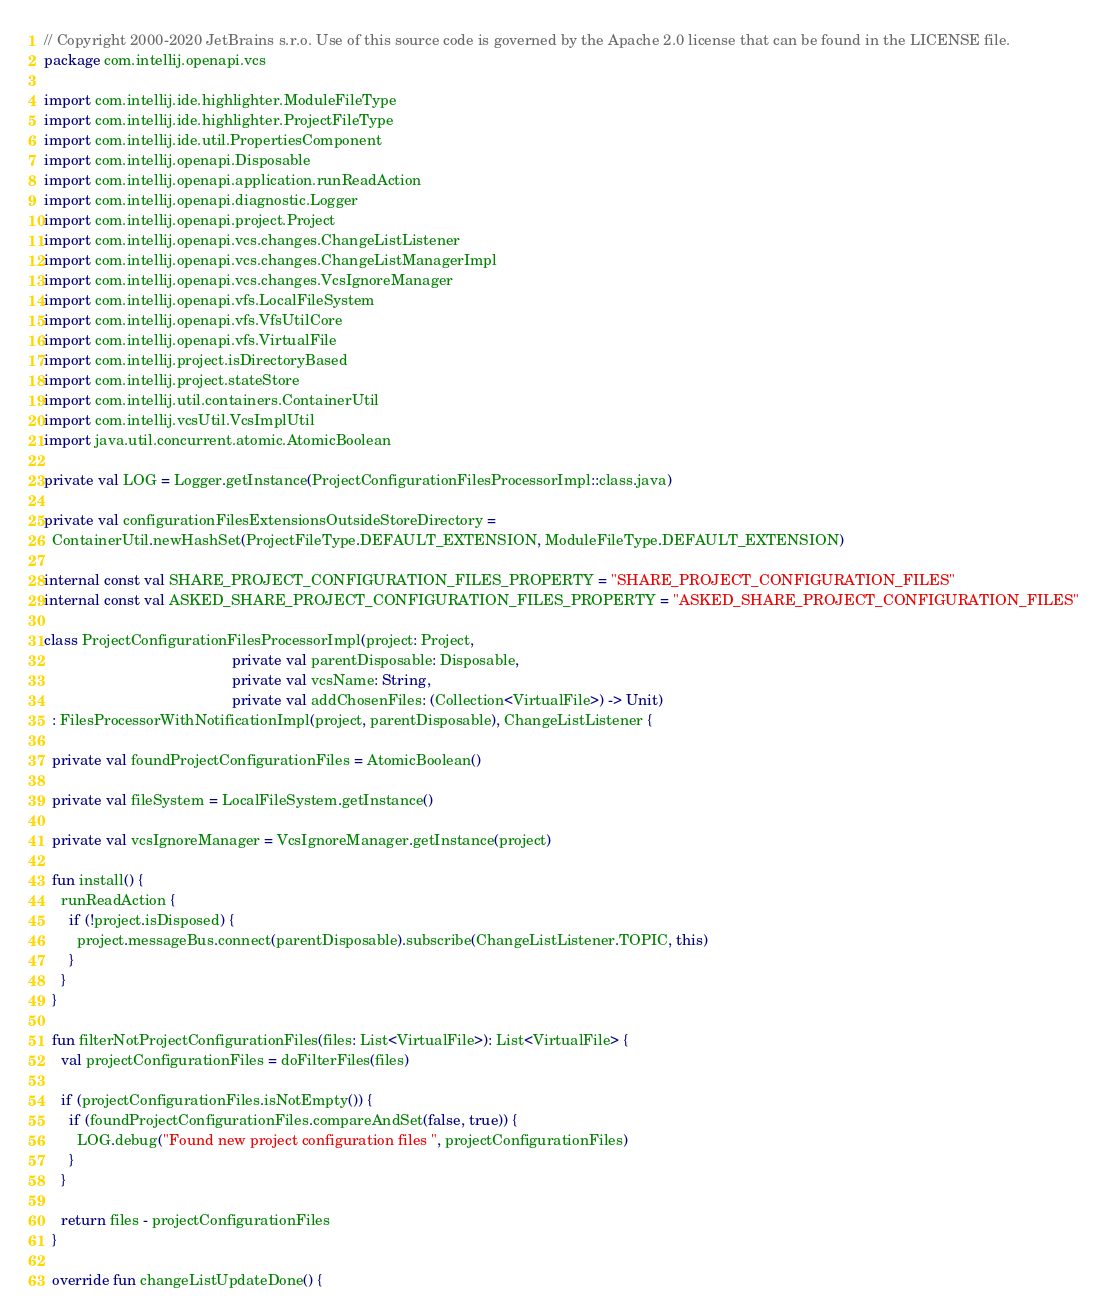Convert code to text. <code><loc_0><loc_0><loc_500><loc_500><_Kotlin_>// Copyright 2000-2020 JetBrains s.r.o. Use of this source code is governed by the Apache 2.0 license that can be found in the LICENSE file.
package com.intellij.openapi.vcs

import com.intellij.ide.highlighter.ModuleFileType
import com.intellij.ide.highlighter.ProjectFileType
import com.intellij.ide.util.PropertiesComponent
import com.intellij.openapi.Disposable
import com.intellij.openapi.application.runReadAction
import com.intellij.openapi.diagnostic.Logger
import com.intellij.openapi.project.Project
import com.intellij.openapi.vcs.changes.ChangeListListener
import com.intellij.openapi.vcs.changes.ChangeListManagerImpl
import com.intellij.openapi.vcs.changes.VcsIgnoreManager
import com.intellij.openapi.vfs.LocalFileSystem
import com.intellij.openapi.vfs.VfsUtilCore
import com.intellij.openapi.vfs.VirtualFile
import com.intellij.project.isDirectoryBased
import com.intellij.project.stateStore
import com.intellij.util.containers.ContainerUtil
import com.intellij.vcsUtil.VcsImplUtil
import java.util.concurrent.atomic.AtomicBoolean

private val LOG = Logger.getInstance(ProjectConfigurationFilesProcessorImpl::class.java)

private val configurationFilesExtensionsOutsideStoreDirectory =
  ContainerUtil.newHashSet(ProjectFileType.DEFAULT_EXTENSION, ModuleFileType.DEFAULT_EXTENSION)

internal const val SHARE_PROJECT_CONFIGURATION_FILES_PROPERTY = "SHARE_PROJECT_CONFIGURATION_FILES"
internal const val ASKED_SHARE_PROJECT_CONFIGURATION_FILES_PROPERTY = "ASKED_SHARE_PROJECT_CONFIGURATION_FILES"

class ProjectConfigurationFilesProcessorImpl(project: Project,
                                             private val parentDisposable: Disposable,
                                             private val vcsName: String,
                                             private val addChosenFiles: (Collection<VirtualFile>) -> Unit)
  : FilesProcessorWithNotificationImpl(project, parentDisposable), ChangeListListener {

  private val foundProjectConfigurationFiles = AtomicBoolean()

  private val fileSystem = LocalFileSystem.getInstance()

  private val vcsIgnoreManager = VcsIgnoreManager.getInstance(project)

  fun install() {
    runReadAction {
      if (!project.isDisposed) {
        project.messageBus.connect(parentDisposable).subscribe(ChangeListListener.TOPIC, this)
      }
    }
  }

  fun filterNotProjectConfigurationFiles(files: List<VirtualFile>): List<VirtualFile> {
    val projectConfigurationFiles = doFilterFiles(files)

    if (projectConfigurationFiles.isNotEmpty()) {
      if (foundProjectConfigurationFiles.compareAndSet(false, true)) {
        LOG.debug("Found new project configuration files ", projectConfigurationFiles)
      }
    }

    return files - projectConfigurationFiles
  }

  override fun changeListUpdateDone() {</code> 